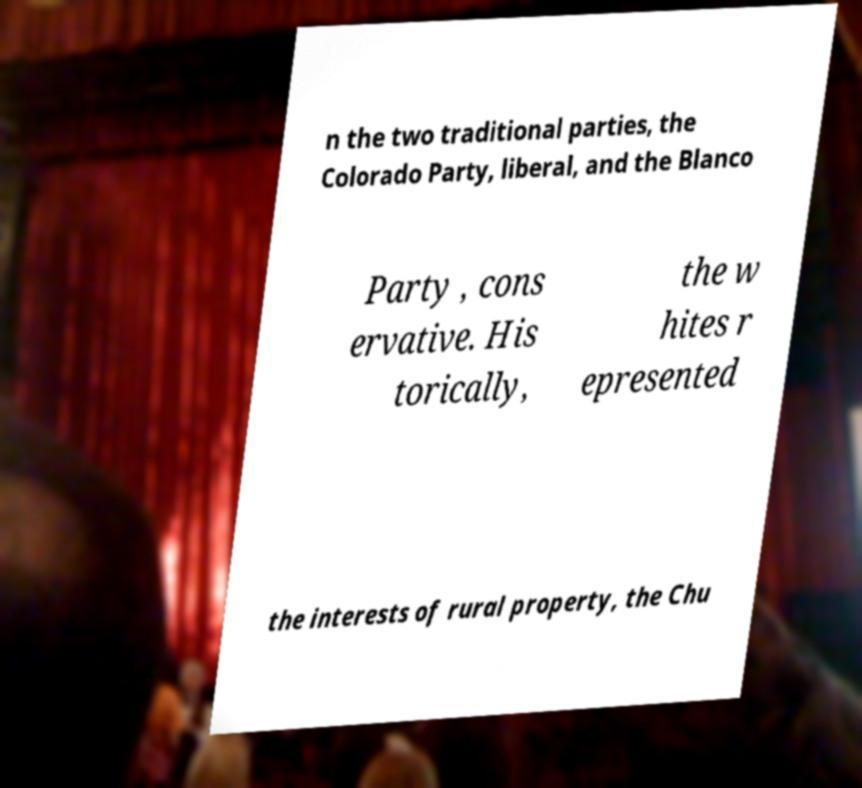I need the written content from this picture converted into text. Can you do that? n the two traditional parties, the Colorado Party, liberal, and the Blanco Party , cons ervative. His torically, the w hites r epresented the interests of rural property, the Chu 